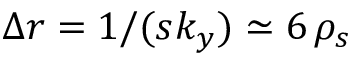Convert formula to latex. <formula><loc_0><loc_0><loc_500><loc_500>\Delta r = 1 / ( s k _ { y } ) \simeq 6 \, \rho _ { s }</formula> 